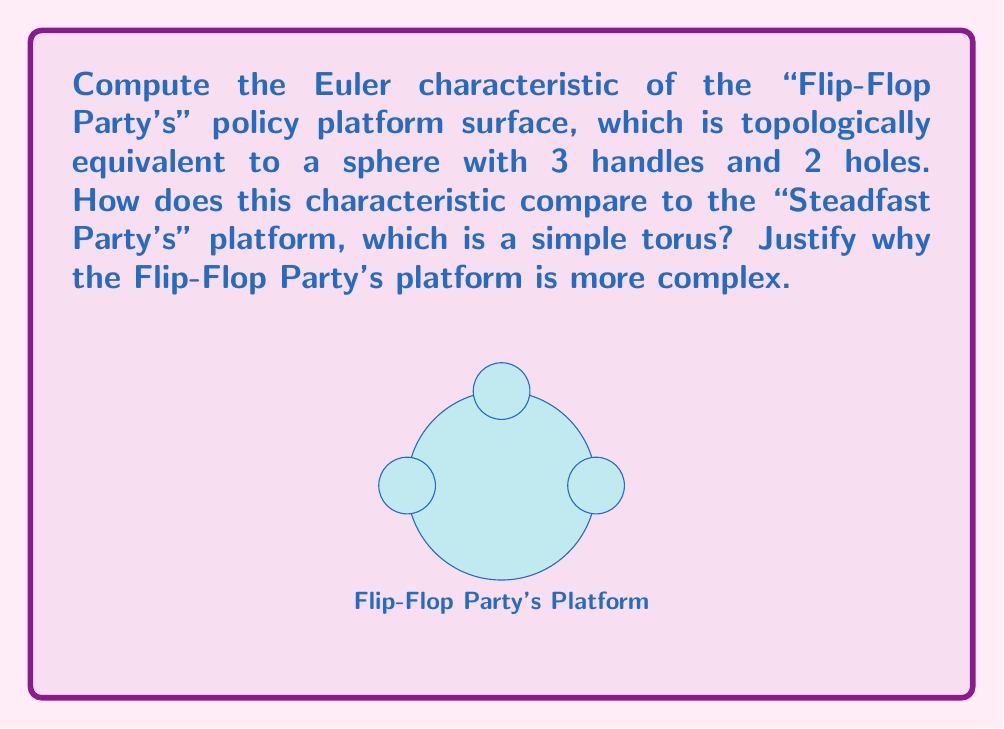Solve this math problem. To solve this problem, we'll use the Euler characteristic formula for a surface:

$$\chi = 2 - 2g - b$$

Where:
$\chi$ is the Euler characteristic
$g$ is the genus (number of handles)
$b$ is the number of boundary components (holes)

For the Flip-Flop Party's platform:
1. It's a sphere (χ = 2) with 3 handles and 2 holes
2. Substituting into the formula:
   $$\chi = 2 - 2(3) - 2 = 2 - 6 - 2 = -6$$

For the Steadfast Party's platform (a simple torus):
1. A torus has genus 1 and no holes
2. Substituting into the formula:
   $$\chi = 2 - 2(1) - 0 = 2 - 2 = 0$$

The Flip-Flop Party's platform is more complex because:
1. It has a lower Euler characteristic (-6 < 0)
2. It has more topological features (handles and holes)
3. These features represent the party's tendency to change positions (flip-flop) on issues, creating a more convoluted policy surface
Answer: $\chi_{\text{Flip-Flop}} = -6$, $\chi_{\text{Steadfast}} = 0$. The Flip-Flop Party's platform is more complex due to its lower Euler characteristic and increased topological features. 